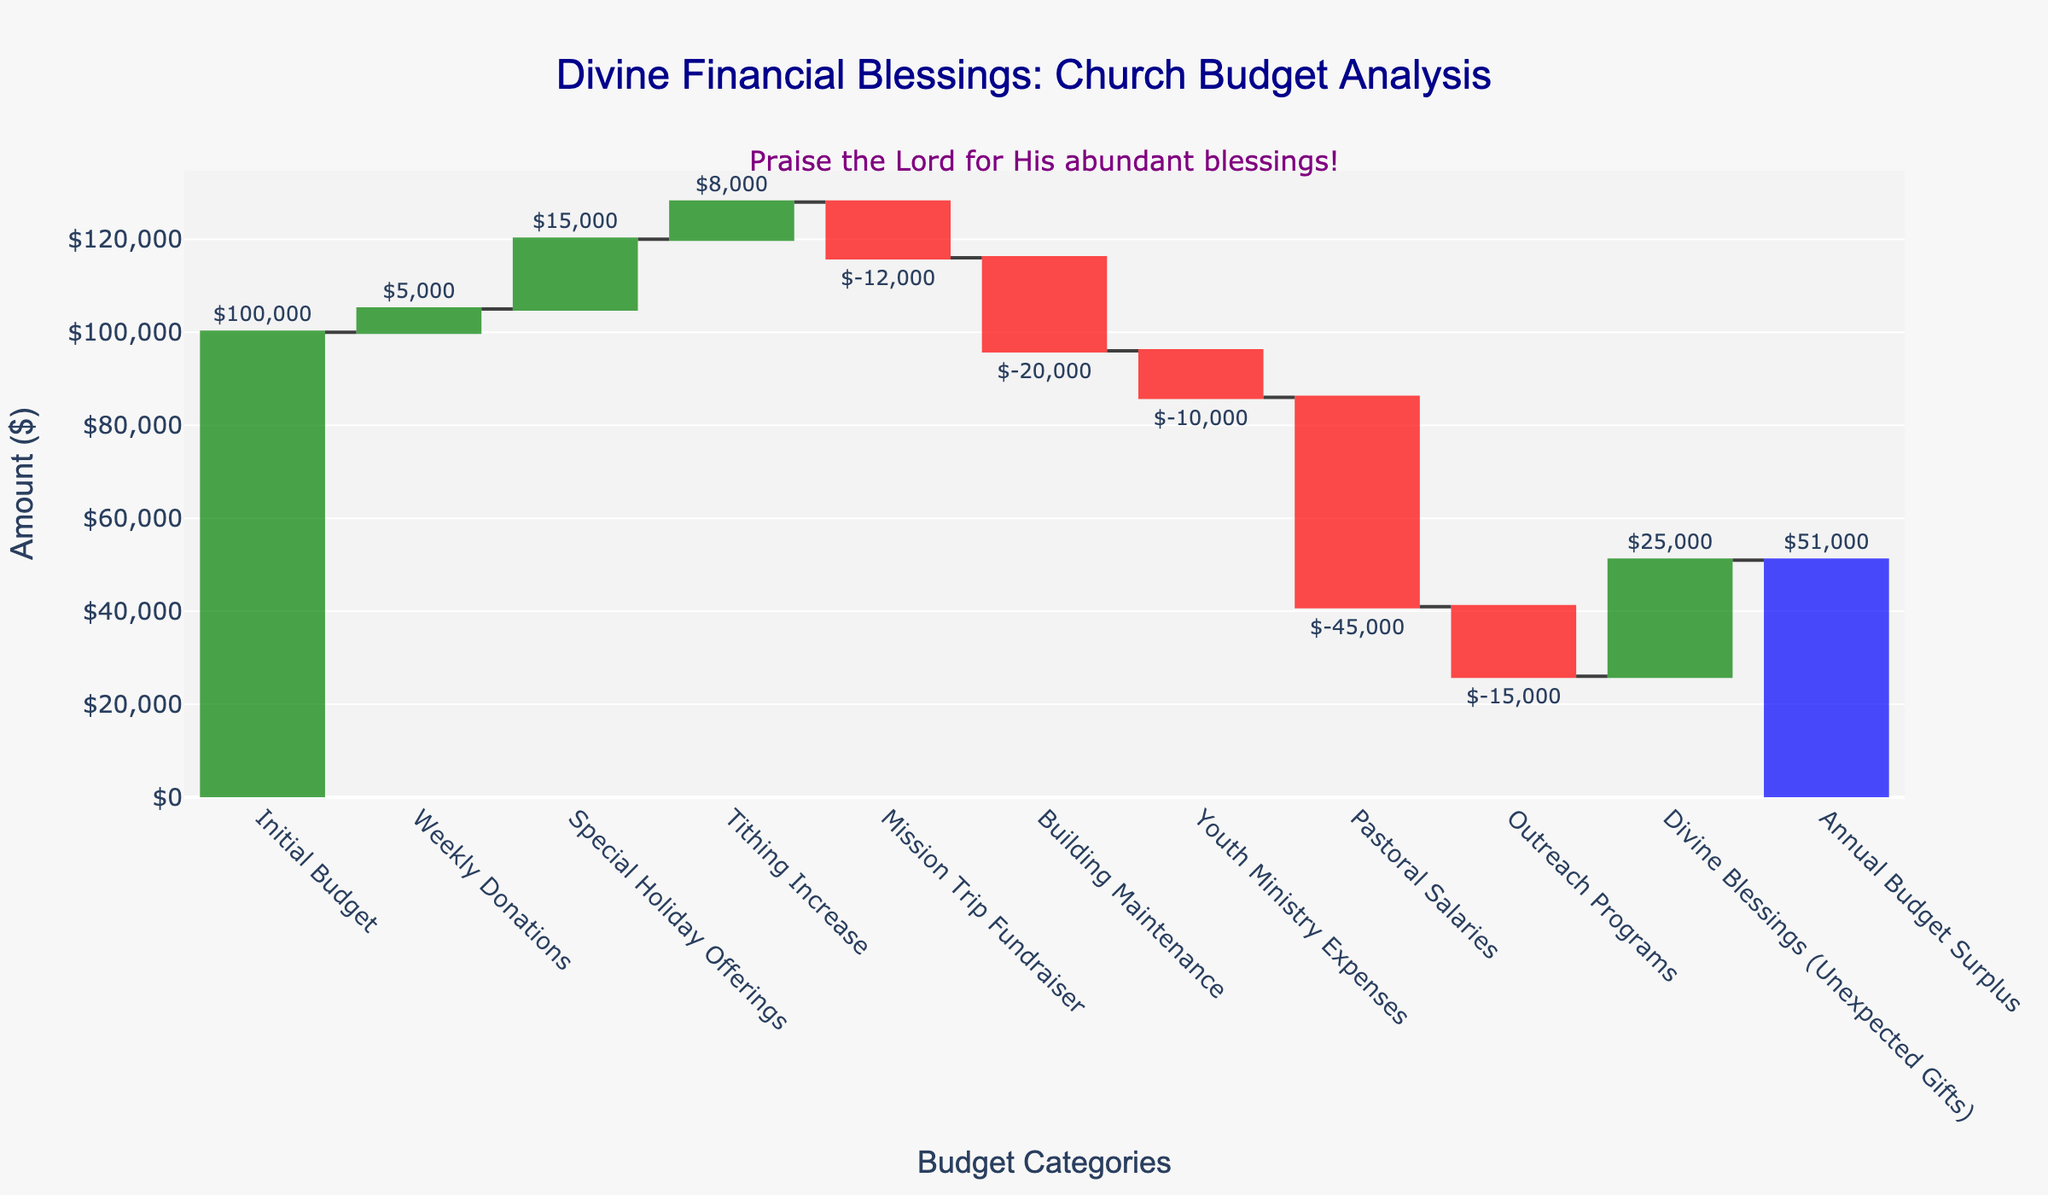How much was the initial budget? The initial budget is shown as the first bar labeled "Initial Budget". The amount stated is $100,000.
Answer: $100,000 What category received the highest amount in donations? By observing the heights of the bars in the increasing (green) category, we find that the "Special Holiday Offerings" bar reaches the highest, indicating the highest amount of $15,000.
Answer: Special Holiday Offerings How did tithing increases affect the budget? The "Tithing Increase" bar is a green increasing bar, indicating a positive contribution to the budget, with an amount of $8,000.
Answer: Increased by $8,000 What was the impact of the mission trip fundraiser on the budget? The "Mission Trip Fundraiser" bar is red, indicating a decrease. The amount shows a reduction of $12,000.
Answer: Decreased by $12,000 What is the total sum of expenses (negative contributions)? Sum all the negative contributions: Mission Trip Fundraiser (-12,000), Building Maintenance (-20,000), Youth Ministry Expenses (-10,000), Pastoral Salaries (-45,000), Outreach Programs (-15,000). Total = -12,000 + (-20,000) + (-10,000) + (-45,000) + (-15,000) = -102,000.
Answer: $102,000 Which category has the smallest impact on the budget? By observing the smallest bar in both positive and negative directions, "Weekly Donations" contributes the least with $5,000.
Answer: Weekly Donations Compare the contributions of divine blessings and pastoral salaries. "Divine Blessings (Unexpected Gifts)" is an increasing blue bar of $25,000 and "Pastoral Salaries" is a decreasing red bar of $45,000. Divine Blessings added $25,000 while Pastoral Salaries reduced the budget by $45,000.
Answer: Divine Blessings added $25,000, Pastoral Salaries reduced $45,000 Calculate the net increase or decrease in the budget after considering Youth Ministry Expenses and Divine Blessings. Youth Ministry Expenses are -$10,000 (decrease) and Divine Blessings are $25,000 (increase). Net = 25,000 + (-10,000) = 15,000.
Answer: Increase by $15,000 Which two categories combined have the largest financial impact? Combining "Pastoral Salaries" (-45,000) and "Divine Blessings (Unexpected Gifts)" (+25,000) yields a net impact of 45,000 + 25,000 = $70,000 in magnitude, with overall impact of $20,000 (net reduction). No other combination reaches this magnitude.
Answer: Pastoral Salaries and Divine Blessings 